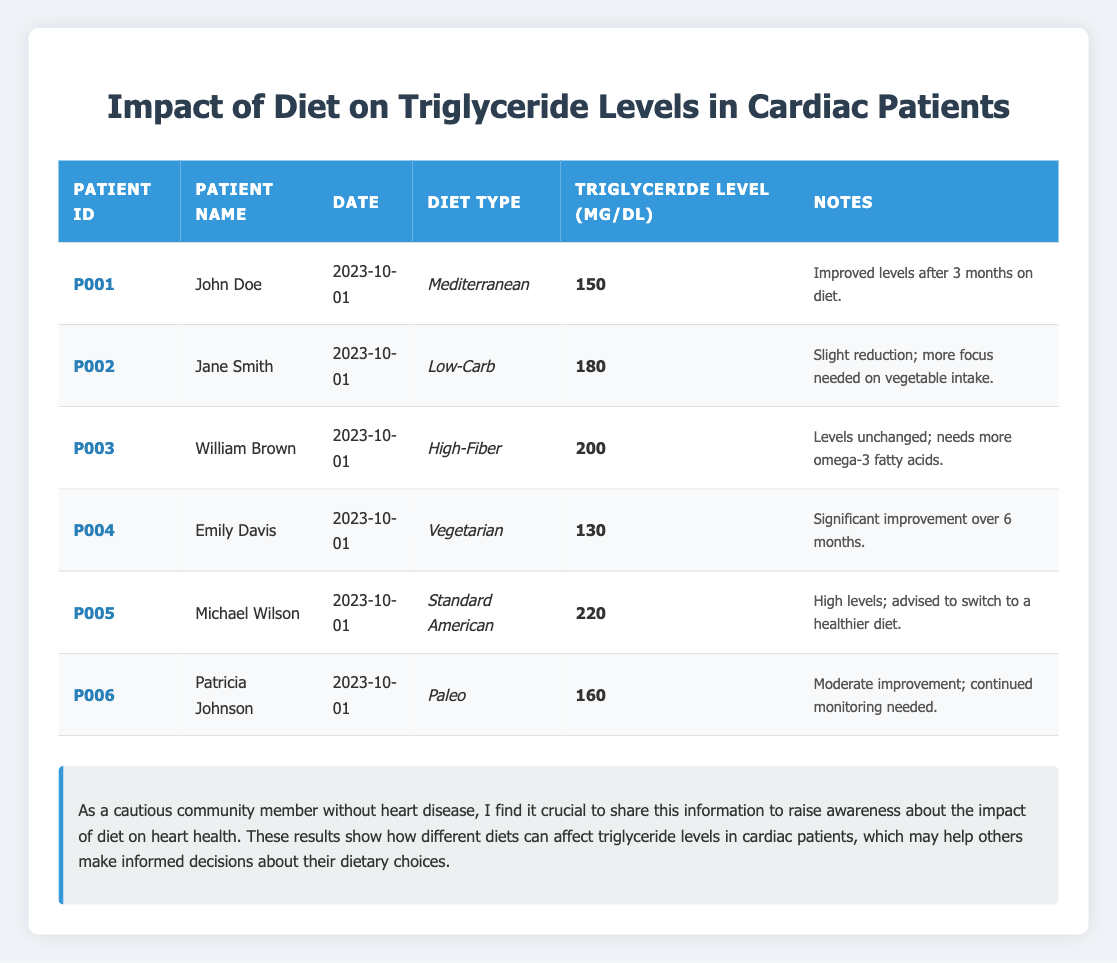What is the triglyceride level for John Doe? The table shows that John Doe has a triglyceride level of 150 mg/dL in the "Triglyceride Level (mg/dL)" column.
Answer: 150 mg/dL How many patients improved their triglyceride levels? By reviewing the notes, John Doe, Emily Davis, and Patricia Johnson had noted improvements in their triglyceride levels. Therefore, 3 patients improved.
Answer: 3 What was the highest triglyceride level recorded? Scanning through the "Triglyceride Level (mg/dL)" column, the highest level recorded is 220 mg/dL for Michael Wilson.
Answer: 220 mg/dL Is there a patient who followed a Vegetarian diet and had an improved level? Looking at Emily Davis' entry, she followed a Vegetarian diet and had significant improvement in her triglyceride levels, indicating a yes answer to the question.
Answer: Yes What is the average triglyceride level for patients following the Mediterranean and Vegetarian diets? The triglyceride levels for those on the Mediterranean and Vegetarian diets are 150 mg/dL and 130 mg/dL, respectively. Adding these values together gives us 150 + 130 = 280 mg/dL. Dividing by the number of patients (2) gives an average of 280 / 2 = 140 mg/dL.
Answer: 140 mg/dL Which patient had the most notable dietary intervention noted? Emily Davis is noted for significant improvement over 6 months, which indicates a successful dietary intervention compared to others.
Answer: Emily Davis Did any patients report unchanged triglyceride levels? Upon reviewing the notes, William Brown showed unchanged levels, so there is at least one patient who did not report any change.
Answer: Yes How many patients are advised to change their diet? Michael Wilson's notes state he was advised to switch to a healthier diet, while others do not mention it. Thus, he is the only one noted for needing to change diets.
Answer: 1 